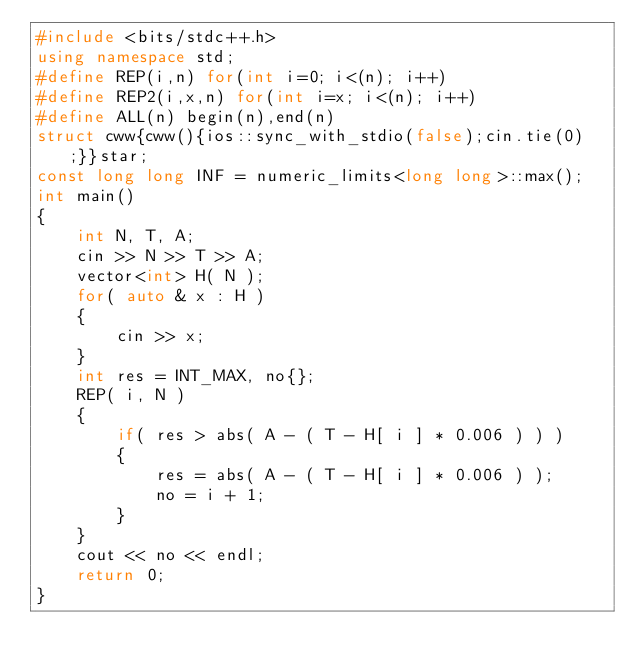Convert code to text. <code><loc_0><loc_0><loc_500><loc_500><_C++_>#include <bits/stdc++.h>
using namespace std;
#define REP(i,n) for(int i=0; i<(n); i++)
#define REP2(i,x,n) for(int i=x; i<(n); i++)
#define ALL(n) begin(n),end(n)
struct cww{cww(){ios::sync_with_stdio(false);cin.tie(0);}}star;
const long long INF = numeric_limits<long long>::max();
int main()
{
    int N, T, A;
    cin >> N >> T >> A;
    vector<int> H( N );
    for( auto & x : H )
    {
        cin >> x;
    }
    int res = INT_MAX, no{};
    REP( i, N )
    {
        if( res > abs( A - ( T - H[ i ] * 0.006 ) ) )
        {
            res = abs( A - ( T - H[ i ] * 0.006 ) );
            no = i + 1;
        }
    }
    cout << no << endl;
    return 0;
}</code> 